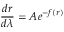Convert formula to latex. <formula><loc_0><loc_0><loc_500><loc_500>\frac { d r } { d \lambda } = A e ^ { - f ( r ) }</formula> 